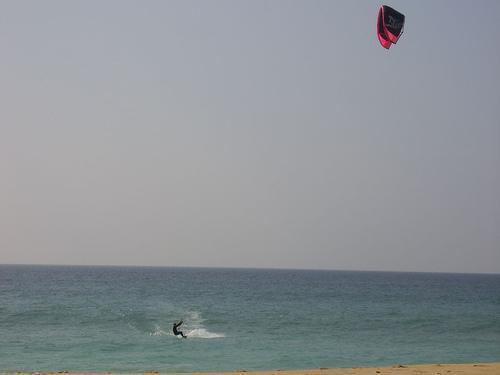How many people are there?
Give a very brief answer. 1. How many people are surfing?
Give a very brief answer. 1. How many people are in the water?
Give a very brief answer. 1. How many ocean waves are in this photo?
Give a very brief answer. 0. 